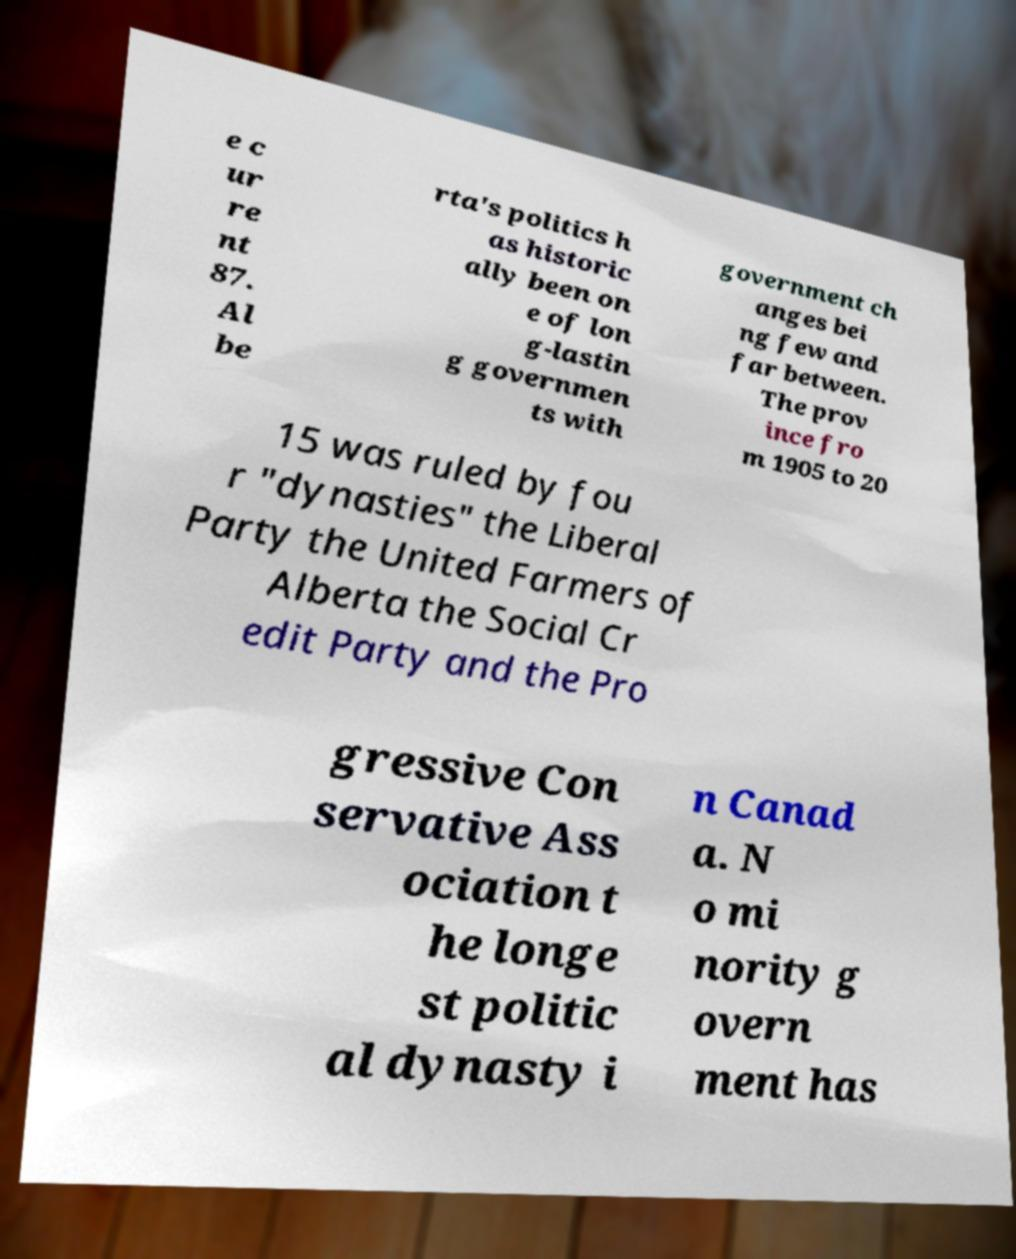Please identify and transcribe the text found in this image. e c ur re nt 87. Al be rta's politics h as historic ally been on e of lon g-lastin g governmen ts with government ch anges bei ng few and far between. The prov ince fro m 1905 to 20 15 was ruled by fou r "dynasties" the Liberal Party the United Farmers of Alberta the Social Cr edit Party and the Pro gressive Con servative Ass ociation t he longe st politic al dynasty i n Canad a. N o mi nority g overn ment has 